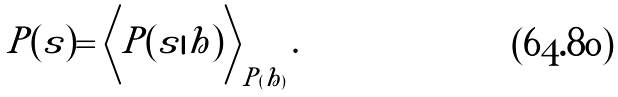Convert formula to latex. <formula><loc_0><loc_0><loc_500><loc_500>P ( s ) = \left \langle P ( s | h ) \right \rangle _ { P ( h ) } .</formula> 